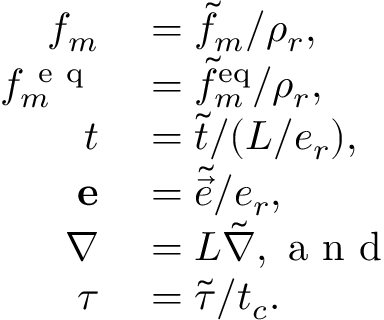Convert formula to latex. <formula><loc_0><loc_0><loc_500><loc_500>\begin{array} { r l } { f _ { m } } & = \tilde { f } _ { m } / \rho _ { r } , } \\ { { f ^ { e q } } _ { m } } & = \tilde { f } _ { m } ^ { e q } / \rho _ { r } , } \\ { t } & = \tilde { t } / ( L / e _ { r } ) , } \\ { { e } } & = \tilde { \vec { e } } / e _ { r } , } \\ { \nabla } & = L \tilde { \nabla } , a n d } \\ { \tau } & = \tilde { \tau } / t _ { c } . } \end{array}</formula> 